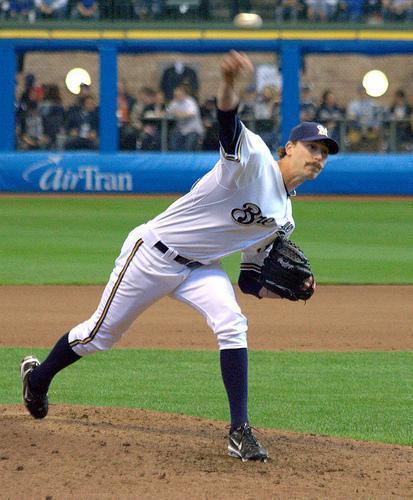How many players are shown?
Give a very brief answer. 1. How many circles of light are behind the player?
Give a very brief answer. 2. 